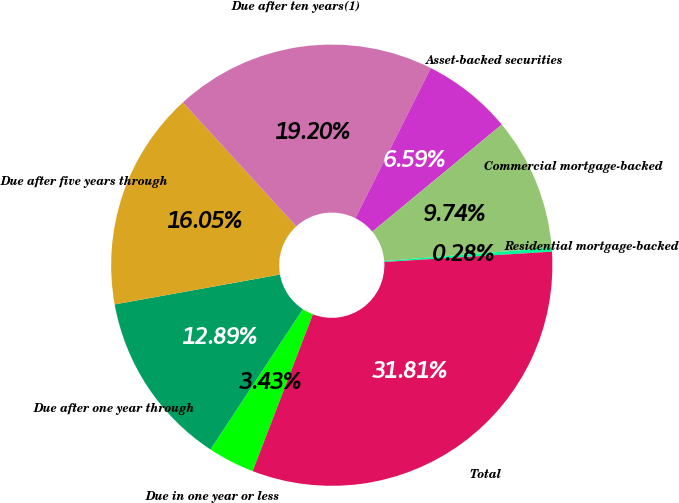Convert chart. <chart><loc_0><loc_0><loc_500><loc_500><pie_chart><fcel>Due in one year or less<fcel>Due after one year through<fcel>Due after five years through<fcel>Due after ten years(1)<fcel>Asset-backed securities<fcel>Commercial mortgage-backed<fcel>Residential mortgage-backed<fcel>Total<nl><fcel>3.43%<fcel>12.89%<fcel>16.05%<fcel>19.2%<fcel>6.59%<fcel>9.74%<fcel>0.28%<fcel>31.81%<nl></chart> 